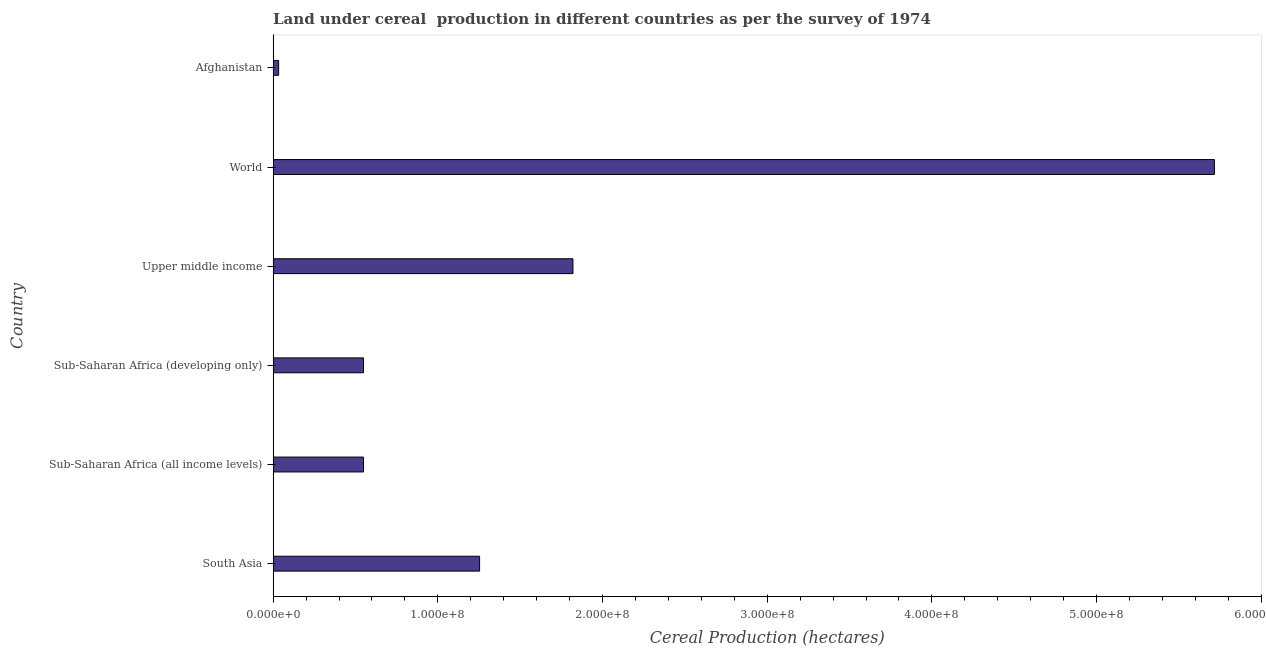What is the title of the graph?
Provide a short and direct response. Land under cereal  production in different countries as per the survey of 1974. What is the label or title of the X-axis?
Ensure brevity in your answer.  Cereal Production (hectares). What is the label or title of the Y-axis?
Provide a succinct answer. Country. What is the land under cereal production in Afghanistan?
Your response must be concise. 3.34e+06. Across all countries, what is the maximum land under cereal production?
Offer a terse response. 5.72e+08. Across all countries, what is the minimum land under cereal production?
Provide a succinct answer. 3.34e+06. In which country was the land under cereal production minimum?
Provide a succinct answer. Afghanistan. What is the sum of the land under cereal production?
Offer a terse response. 9.92e+08. What is the difference between the land under cereal production in Afghanistan and Upper middle income?
Your answer should be very brief. -1.79e+08. What is the average land under cereal production per country?
Ensure brevity in your answer.  1.65e+08. What is the median land under cereal production?
Your answer should be compact. 9.01e+07. What is the ratio of the land under cereal production in Sub-Saharan Africa (developing only) to that in World?
Offer a very short reply. 0.1. What is the difference between the highest and the second highest land under cereal production?
Your response must be concise. 3.90e+08. What is the difference between the highest and the lowest land under cereal production?
Ensure brevity in your answer.  5.68e+08. In how many countries, is the land under cereal production greater than the average land under cereal production taken over all countries?
Offer a terse response. 2. Are all the bars in the graph horizontal?
Offer a very short reply. Yes. What is the difference between two consecutive major ticks on the X-axis?
Provide a short and direct response. 1.00e+08. Are the values on the major ticks of X-axis written in scientific E-notation?
Keep it short and to the point. Yes. What is the Cereal Production (hectares) of South Asia?
Offer a very short reply. 1.25e+08. What is the Cereal Production (hectares) in Sub-Saharan Africa (all income levels)?
Provide a succinct answer. 5.49e+07. What is the Cereal Production (hectares) of Sub-Saharan Africa (developing only)?
Provide a succinct answer. 5.49e+07. What is the Cereal Production (hectares) of Upper middle income?
Provide a succinct answer. 1.82e+08. What is the Cereal Production (hectares) in World?
Keep it short and to the point. 5.72e+08. What is the Cereal Production (hectares) of Afghanistan?
Your answer should be very brief. 3.34e+06. What is the difference between the Cereal Production (hectares) in South Asia and Sub-Saharan Africa (all income levels)?
Offer a terse response. 7.05e+07. What is the difference between the Cereal Production (hectares) in South Asia and Sub-Saharan Africa (developing only)?
Keep it short and to the point. 7.05e+07. What is the difference between the Cereal Production (hectares) in South Asia and Upper middle income?
Your response must be concise. -5.67e+07. What is the difference between the Cereal Production (hectares) in South Asia and World?
Provide a short and direct response. -4.46e+08. What is the difference between the Cereal Production (hectares) in South Asia and Afghanistan?
Your response must be concise. 1.22e+08. What is the difference between the Cereal Production (hectares) in Sub-Saharan Africa (all income levels) and Upper middle income?
Ensure brevity in your answer.  -1.27e+08. What is the difference between the Cereal Production (hectares) in Sub-Saharan Africa (all income levels) and World?
Offer a very short reply. -5.17e+08. What is the difference between the Cereal Production (hectares) in Sub-Saharan Africa (all income levels) and Afghanistan?
Offer a very short reply. 5.16e+07. What is the difference between the Cereal Production (hectares) in Sub-Saharan Africa (developing only) and Upper middle income?
Your answer should be very brief. -1.27e+08. What is the difference between the Cereal Production (hectares) in Sub-Saharan Africa (developing only) and World?
Keep it short and to the point. -5.17e+08. What is the difference between the Cereal Production (hectares) in Sub-Saharan Africa (developing only) and Afghanistan?
Make the answer very short. 5.16e+07. What is the difference between the Cereal Production (hectares) in Upper middle income and World?
Keep it short and to the point. -3.90e+08. What is the difference between the Cereal Production (hectares) in Upper middle income and Afghanistan?
Offer a terse response. 1.79e+08. What is the difference between the Cereal Production (hectares) in World and Afghanistan?
Keep it short and to the point. 5.68e+08. What is the ratio of the Cereal Production (hectares) in South Asia to that in Sub-Saharan Africa (all income levels)?
Your answer should be compact. 2.28. What is the ratio of the Cereal Production (hectares) in South Asia to that in Sub-Saharan Africa (developing only)?
Provide a succinct answer. 2.28. What is the ratio of the Cereal Production (hectares) in South Asia to that in Upper middle income?
Make the answer very short. 0.69. What is the ratio of the Cereal Production (hectares) in South Asia to that in World?
Provide a succinct answer. 0.22. What is the ratio of the Cereal Production (hectares) in South Asia to that in Afghanistan?
Keep it short and to the point. 37.51. What is the ratio of the Cereal Production (hectares) in Sub-Saharan Africa (all income levels) to that in Sub-Saharan Africa (developing only)?
Your answer should be compact. 1. What is the ratio of the Cereal Production (hectares) in Sub-Saharan Africa (all income levels) to that in Upper middle income?
Provide a succinct answer. 0.3. What is the ratio of the Cereal Production (hectares) in Sub-Saharan Africa (all income levels) to that in World?
Provide a short and direct response. 0.1. What is the ratio of the Cereal Production (hectares) in Sub-Saharan Africa (all income levels) to that in Afghanistan?
Your response must be concise. 16.43. What is the ratio of the Cereal Production (hectares) in Sub-Saharan Africa (developing only) to that in Upper middle income?
Give a very brief answer. 0.3. What is the ratio of the Cereal Production (hectares) in Sub-Saharan Africa (developing only) to that in World?
Give a very brief answer. 0.1. What is the ratio of the Cereal Production (hectares) in Sub-Saharan Africa (developing only) to that in Afghanistan?
Offer a terse response. 16.43. What is the ratio of the Cereal Production (hectares) in Upper middle income to that in World?
Make the answer very short. 0.32. What is the ratio of the Cereal Production (hectares) in Upper middle income to that in Afghanistan?
Your answer should be compact. 54.47. What is the ratio of the Cereal Production (hectares) in World to that in Afghanistan?
Make the answer very short. 171.02. 